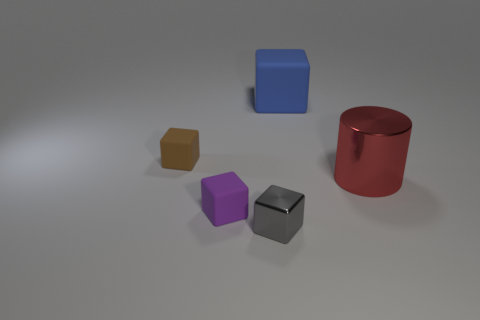Subtract all big blue blocks. How many blocks are left? 3 Add 4 gray matte balls. How many objects exist? 9 Subtract all gray blocks. How many blocks are left? 3 Subtract 1 cylinders. How many cylinders are left? 0 Subtract all cylinders. How many objects are left? 4 Subtract all purple spheres. How many blue cylinders are left? 0 Subtract all matte things. Subtract all small gray metal things. How many objects are left? 1 Add 1 brown rubber objects. How many brown rubber objects are left? 2 Add 3 large purple shiny cylinders. How many large purple shiny cylinders exist? 3 Subtract 1 blue cubes. How many objects are left? 4 